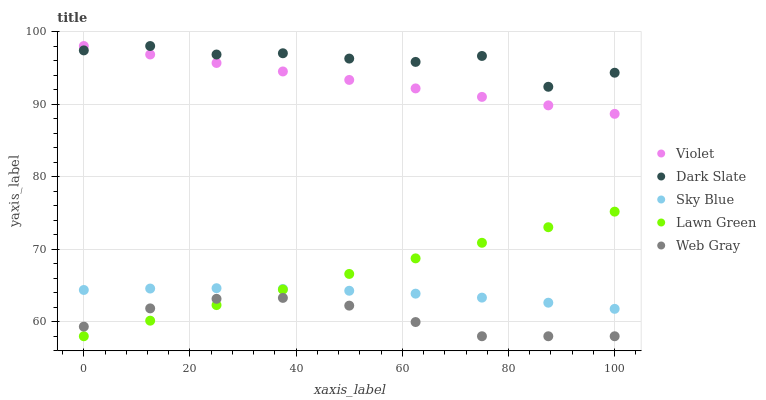Does Web Gray have the minimum area under the curve?
Answer yes or no. Yes. Does Dark Slate have the maximum area under the curve?
Answer yes or no. Yes. Does Sky Blue have the minimum area under the curve?
Answer yes or no. No. Does Sky Blue have the maximum area under the curve?
Answer yes or no. No. Is Lawn Green the smoothest?
Answer yes or no. Yes. Is Dark Slate the roughest?
Answer yes or no. Yes. Is Sky Blue the smoothest?
Answer yes or no. No. Is Sky Blue the roughest?
Answer yes or no. No. Does Web Gray have the lowest value?
Answer yes or no. Yes. Does Sky Blue have the lowest value?
Answer yes or no. No. Does Violet have the highest value?
Answer yes or no. Yes. Does Sky Blue have the highest value?
Answer yes or no. No. Is Web Gray less than Dark Slate?
Answer yes or no. Yes. Is Dark Slate greater than Sky Blue?
Answer yes or no. Yes. Does Sky Blue intersect Lawn Green?
Answer yes or no. Yes. Is Sky Blue less than Lawn Green?
Answer yes or no. No. Is Sky Blue greater than Lawn Green?
Answer yes or no. No. Does Web Gray intersect Dark Slate?
Answer yes or no. No. 